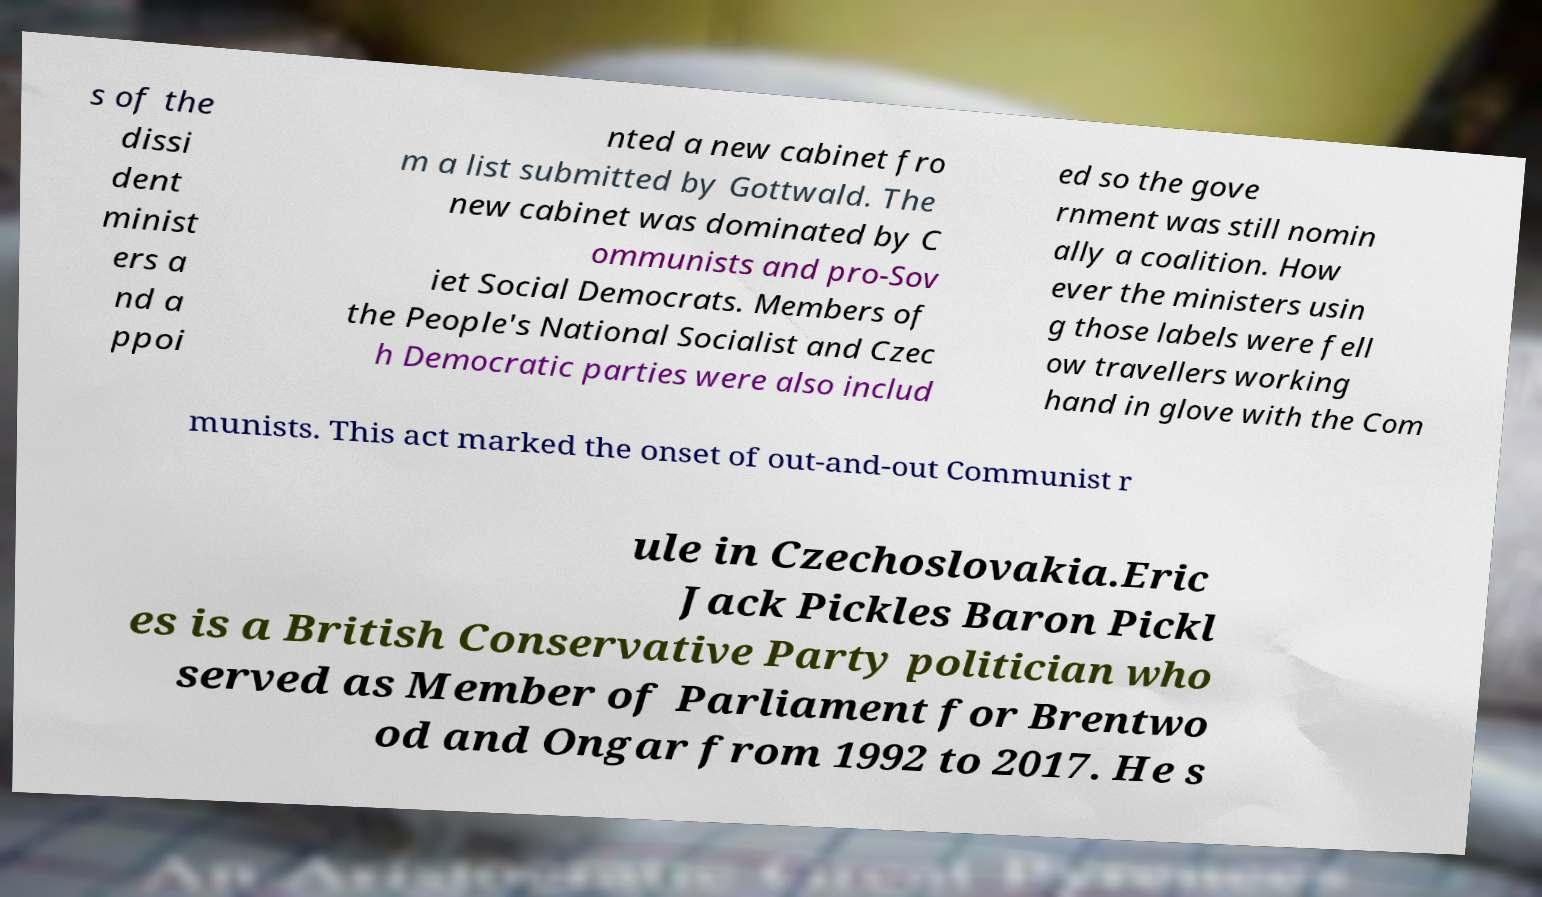Can you read and provide the text displayed in the image?This photo seems to have some interesting text. Can you extract and type it out for me? s of the dissi dent minist ers a nd a ppoi nted a new cabinet fro m a list submitted by Gottwald. The new cabinet was dominated by C ommunists and pro-Sov iet Social Democrats. Members of the People's National Socialist and Czec h Democratic parties were also includ ed so the gove rnment was still nomin ally a coalition. How ever the ministers usin g those labels were fell ow travellers working hand in glove with the Com munists. This act marked the onset of out-and-out Communist r ule in Czechoslovakia.Eric Jack Pickles Baron Pickl es is a British Conservative Party politician who served as Member of Parliament for Brentwo od and Ongar from 1992 to 2017. He s 